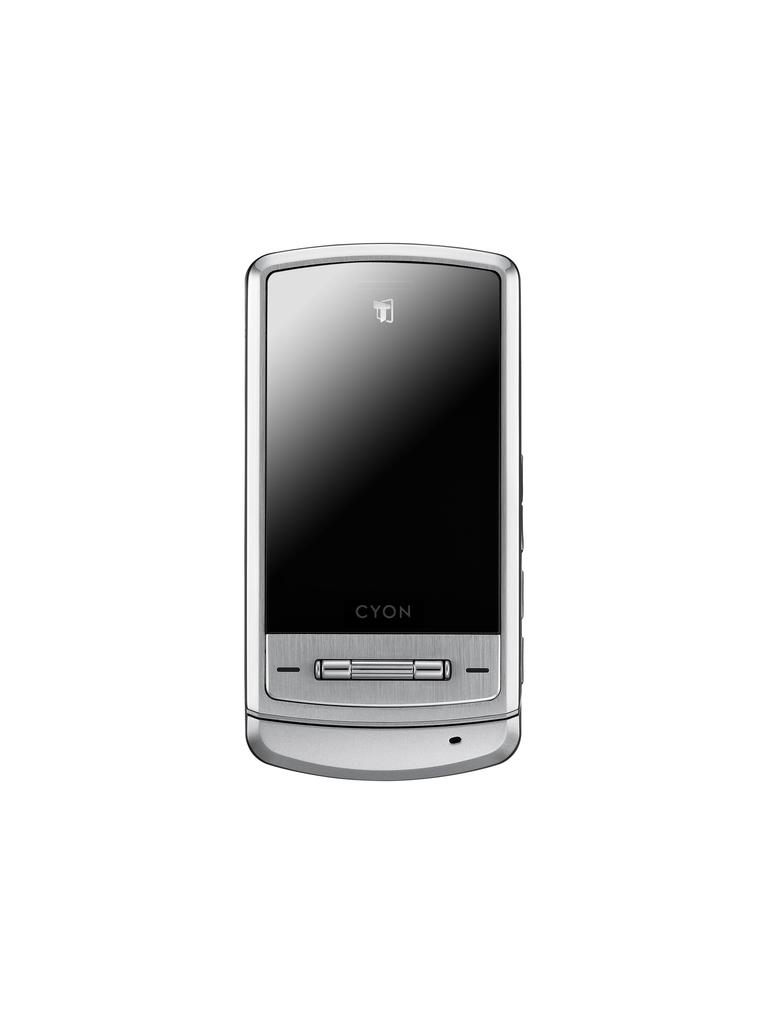What color is the background of the image? The background of the image is white. What electronic device can be seen in the image? There is a mobile phone in the image. What is the color of the mobile phone? The mobile phone is silver in color. How many beans are scattered on the floor in the image? There are no beans present in the image. Is there an owl perched on the mobile phone in the image? There is no owl present in the image. 